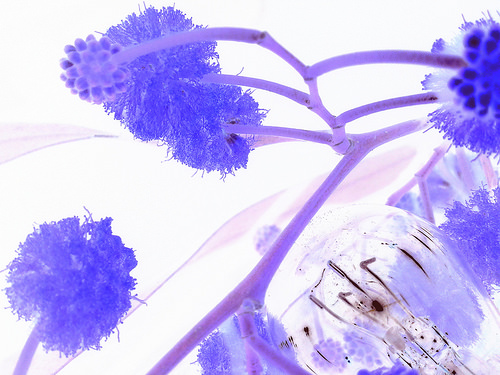<image>
Is there a seed pod behind the poofy thing? No. The seed pod is not behind the poofy thing. From this viewpoint, the seed pod appears to be positioned elsewhere in the scene. 